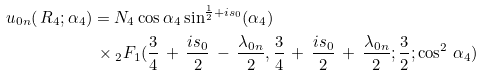<formula> <loc_0><loc_0><loc_500><loc_500>u _ { 0 n } ( \, R _ { 4 } ; \alpha _ { 4 } ) & = N _ { 4 } \cos \alpha _ { 4 } \sin ^ { \frac { 1 } { 2 } + i s _ { 0 } } ( \alpha _ { 4 } ) \\ & \, \times { _ { 2 } { F } _ { 1 } } ( \frac { 3 } { 4 } \, + \, \frac { i s _ { 0 } } { 2 } \, - \, \frac { \lambda _ { 0 n } } { 2 } , \frac { 3 } { 4 } \, + \, \frac { i s _ { 0 } } { 2 } \, + \, \frac { \lambda _ { 0 n } } { 2 } ; \frac { 3 } { 2 } ; \cos ^ { 2 } \, \alpha _ { 4 } )</formula> 